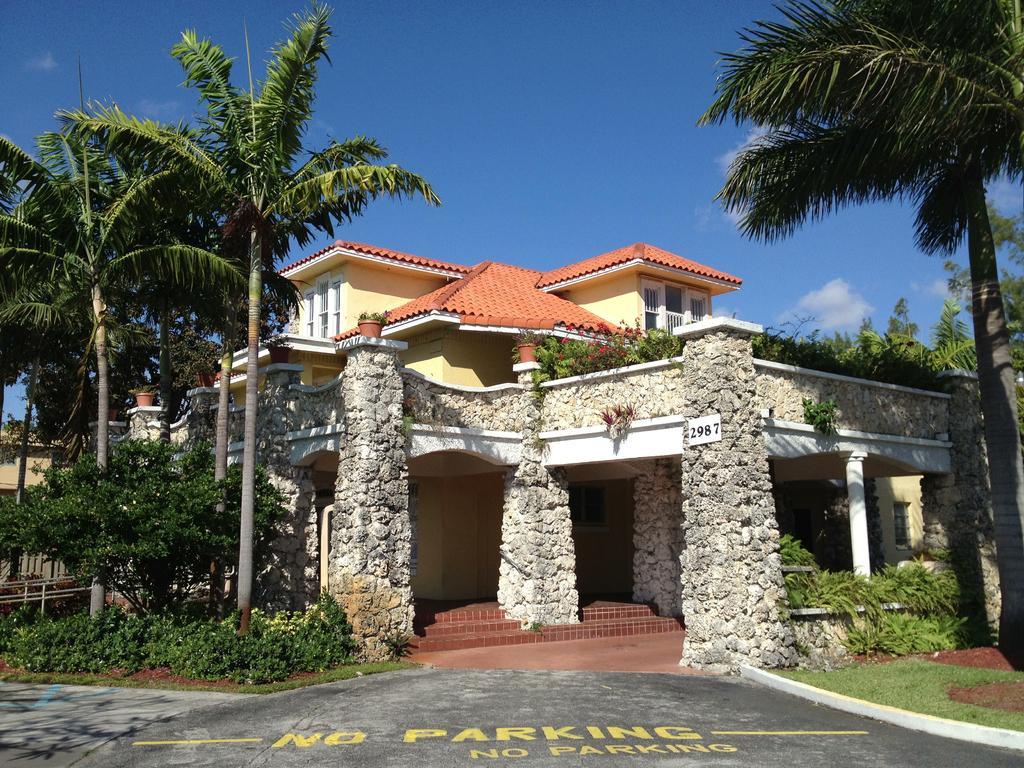Could you give a brief overview of what you see in this image? There are trees, plants and a house in the foreground area of the image and the sky in the background. 